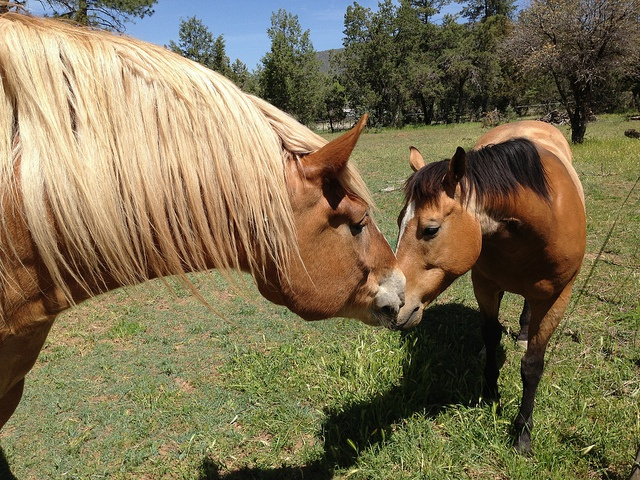Describe the objects in this image and their specific colors. I can see horse in gray and tan tones and horse in gray, black, brown, and maroon tones in this image. 